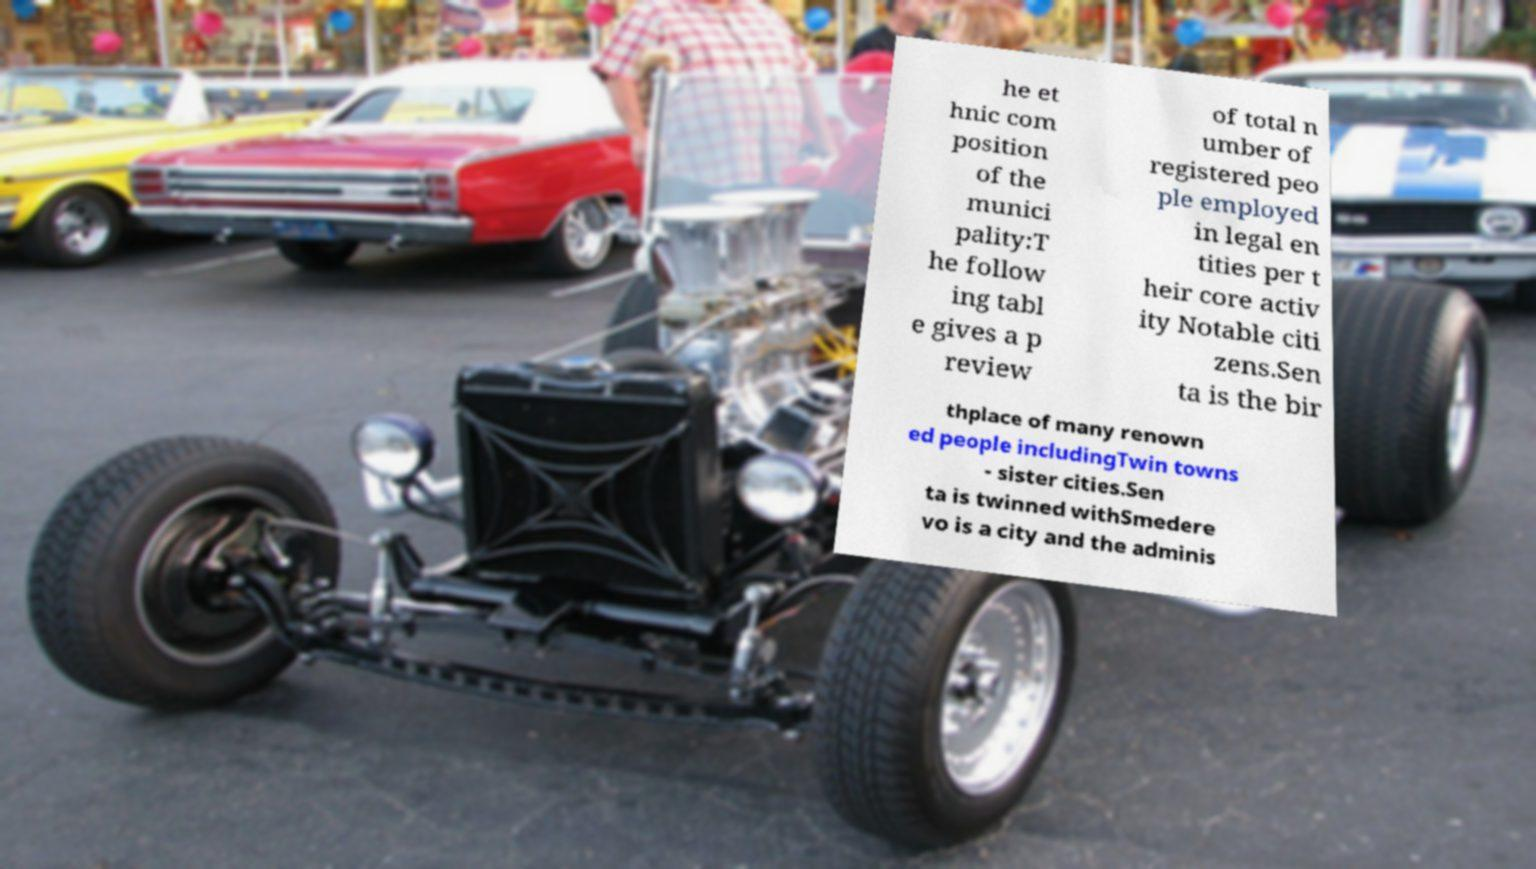What messages or text are displayed in this image? I need them in a readable, typed format. he et hnic com position of the munici pality:T he follow ing tabl e gives a p review of total n umber of registered peo ple employed in legal en tities per t heir core activ ity Notable citi zens.Sen ta is the bir thplace of many renown ed people includingTwin towns - sister cities.Sen ta is twinned withSmedere vo is a city and the adminis 